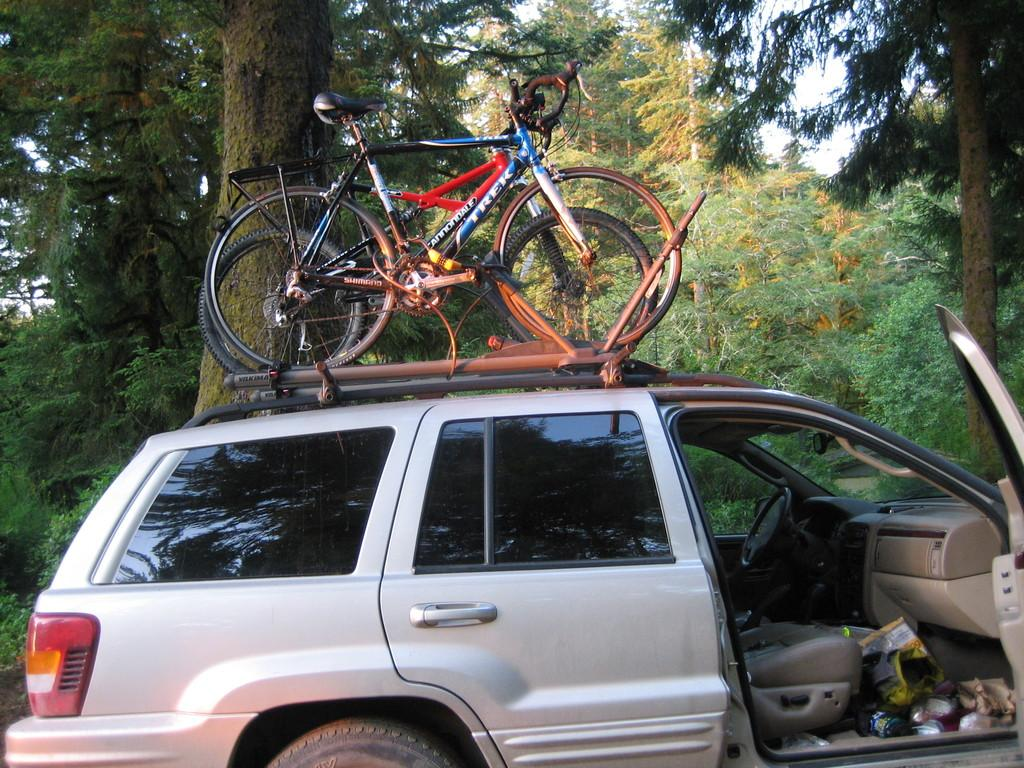What is the main subject of the image? There is a car in the image. What can be seen inside the car? There are objects inside the car. How are the bicycles positioned in relation to the car? There are two bicycles on the car. What type of natural scenery is visible in the image? There are trees visible in the image. What is visible in the background of the image? The sky is visible in the image. What type of meat is being cooked on the grill in the image? There is no grill or meat present in the image; it features a car with bicycles and objects inside. 